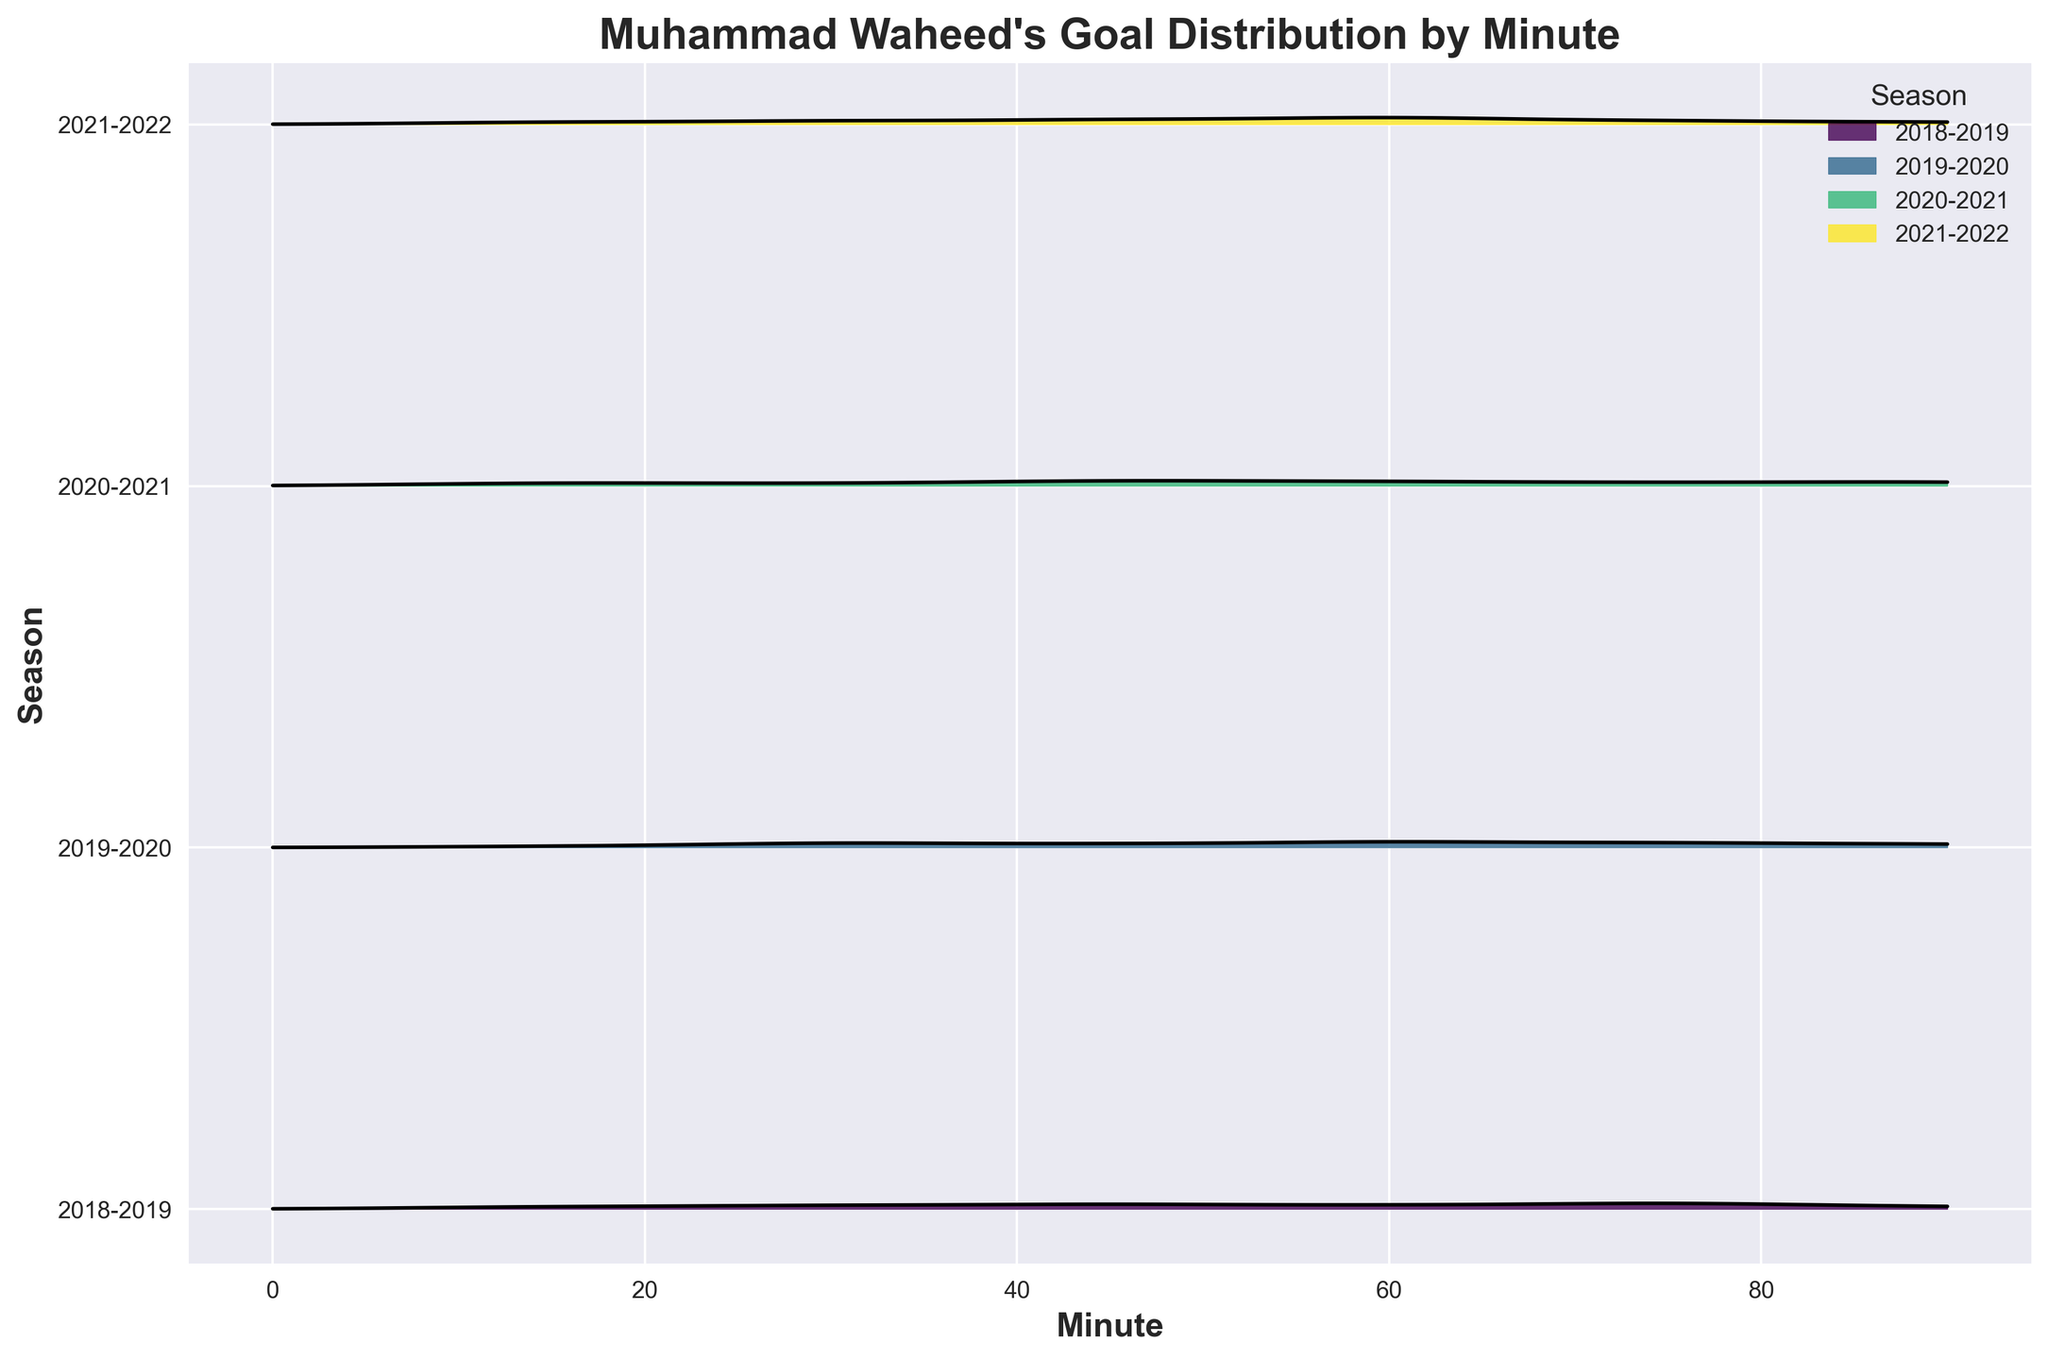Which season has the highest peak of goals scored around the 60th minute? To determine the season with the highest peak around the 60th minute, observe the goal distribution curves in the vicinity of the 60th minute. The 2021-2022 season has the highest peak in this region.
Answer: 2021-2022 What is the title of the plot? Look at the top of the plot; it should state the title in bold text.
Answer: Muhammad Waheed's Goal Distribution by Minute How many seasons are shown in the plot? Count the number of unique ridgelines in the plot, each line represents a season.
Answer: 4 During which season did Waheed score the least number of goals around the 15th minute? Compare the heights of the curves at the 15th minute mark across different seasons. The 2019-2020 season has the lowest height at this point.
Answer: 2019-2020 Which season shows a peak in goals scored around the 75th minute? Locate the 75th minute mark and observe which seasons have peaks around this point. Both the 2018-2019 and 2019-2020 seasons show noticeable peaks around this minute.
Answer: 2018-2019 and 2019-2020 Is the distribution of goals more spread out in the 2020-2021 season compared to the 2018-2019 season? Compare the width and spread of the goal distribution curves for each season. The 2020-2021 season has a wider distribution curve compared to the 2018-2019 season.
Answer: Yes Which season has the most goals scored as indicated by the peak height? Identify the tallest peak among all seasons in the plot. The tallest peak occurs in the 2021-2022 season around the 60th minute.
Answer: 2021-2022 What is the color of the ridge corresponding to the 2019-2020 season? Match the color of the ridge to the legend on the plot, which identifies seasons by color.
Answer: Greenish Between the 45th and 60th minutes, which season shows a rapid increase in goals? Observe the slope of the curves between the 45th and 60th minutes for all seasons. The 2021-2022 season shows a rapid increase in this period.
Answer: 2021-2022 